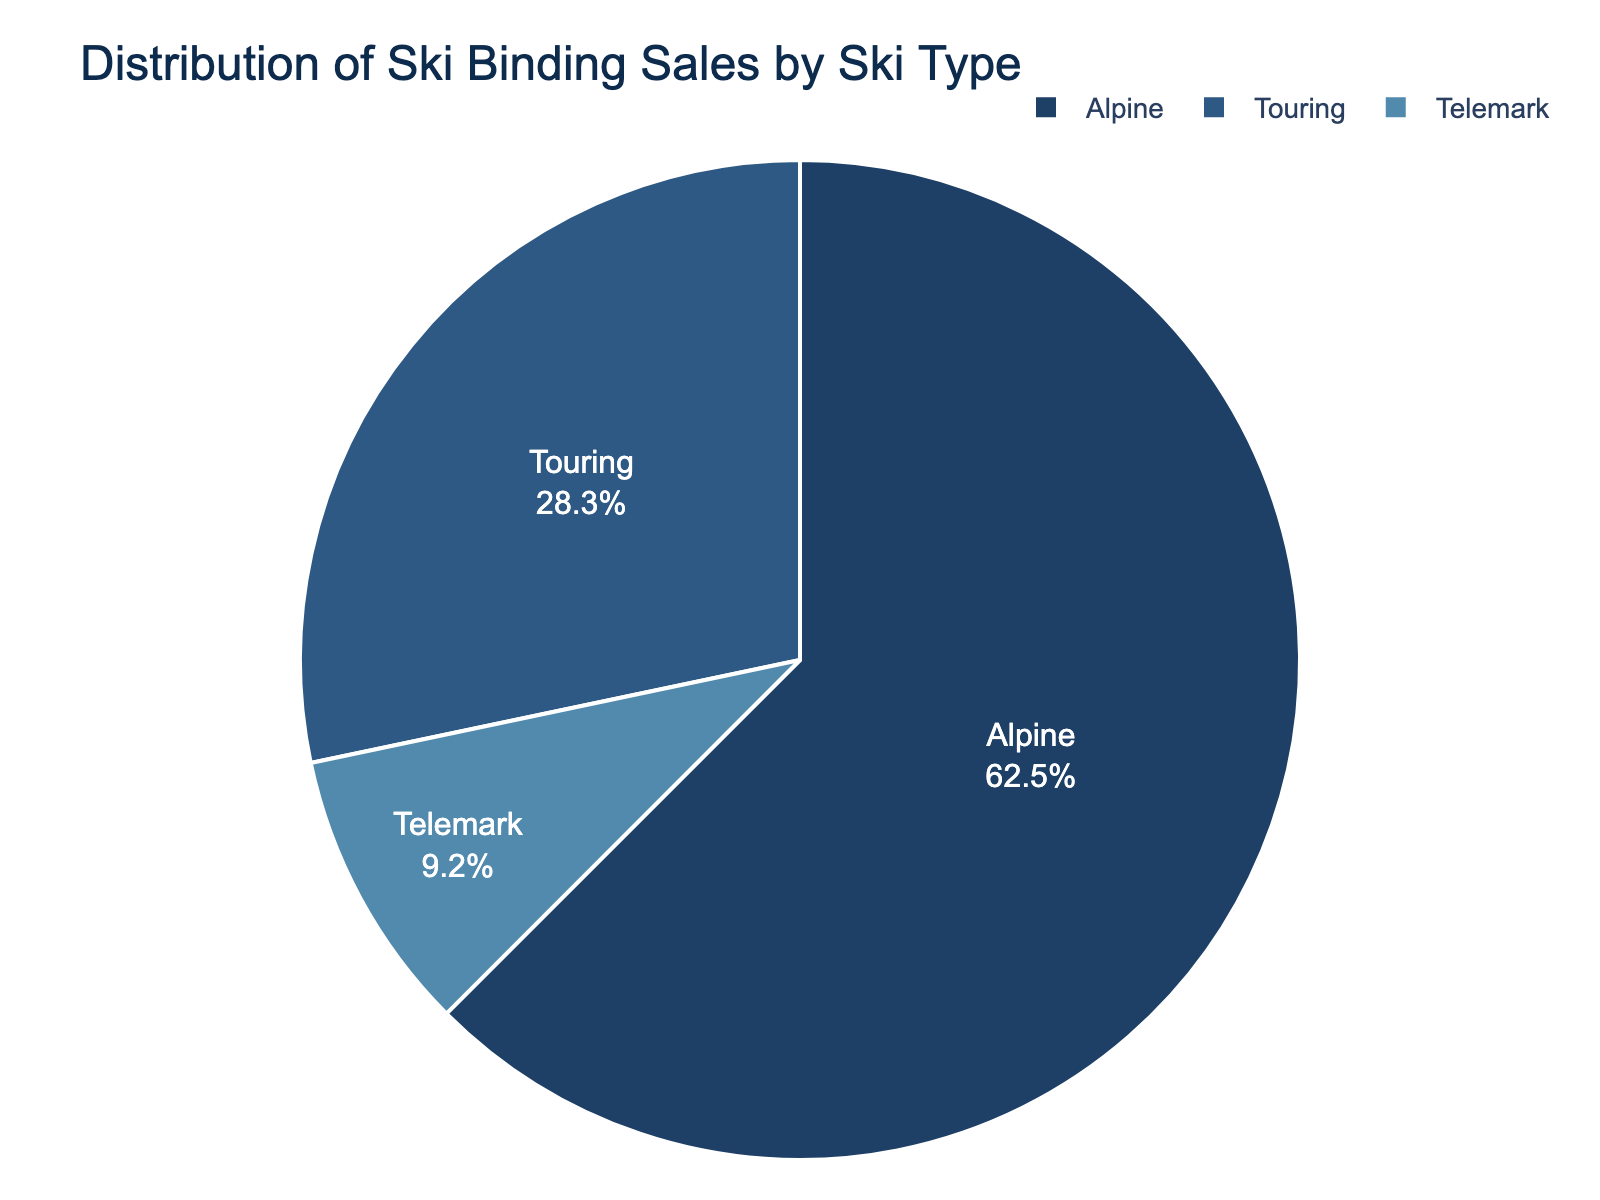What percentage of ski binding sales are for Alpine ski types? Look at the pie chart and identify the section labeled "Alpine," then note its percentage.
Answer: 62.5% How does the percentage of Touring ski bindings compare to that of Telemark ski bindings? Look at the pie chart and compare the sections labeled "Touring" (28.3%) and "Telemark" (9.2%). Calculate the difference: 28.3% - 9.2%.
Answer: Touring is 19.1% higher than Telemark Which ski type has the lowest percentage of ski binding sales? Observe the pie chart and identify the smallest section by its percentage value.
Answer: Telemark If the total number of ski bindings sold is 2000, how many of each ski type were sold? Calculate the number for each type by multiplying the total sales by the respective percentage: Alpine: 2000 * 62.5% = 1250, Touring: 2000 * 28.3% = 566, Telemark: 2000 * 9.2% = 184.
Answer: Alpine: 1250, Touring: 566, Telemark: 184 What is the combined percentage of Alpine and Touring ski bindings? Sum the percentages of the Alpine (62.5%) and Touring (28.3%) sections.
Answer: 90.8% By how much does the percentage of Alpine ski bindings exceed that of Touring ski bindings? Subtract the percentage of Touring (28.3%) from Alpine (62.5%): 62.5% - 28.3%.
Answer: 34.2% What color represents the Telemark ski bindings in the pie chart? Locate the section labeled "Telemark" in the pie chart and identify its color.
Answer: Light blue What visual feature helps you differentiate between the various sections of the pie chart? Identify the visual attributes like color and text labels that distinguish between the different sections.
Answer: Colors and Label Names Is the sales distribution of ski bindings skewed towards a particular ski type? Examine if one section is significantly larger than the others. The significantly larger Alpine section indicates a skew.
Answer: Yes, skewed towards Alpine 